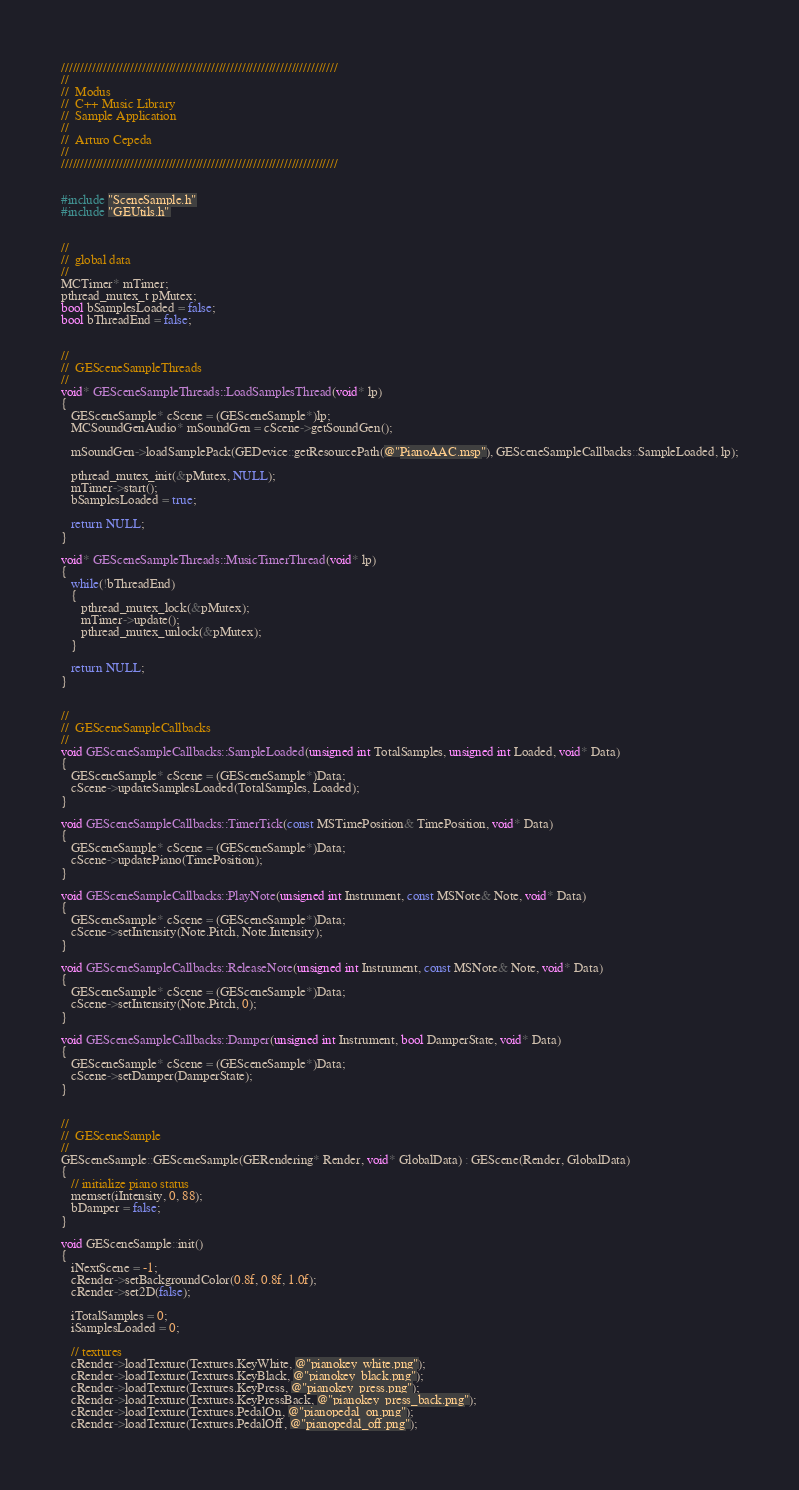<code> <loc_0><loc_0><loc_500><loc_500><_ObjectiveC_>
////////////////////////////////////////////////////////////////////////
//
//  Modus
//  C++ Music Library
//  Sample Application
//
//  Arturo Cepeda
//
////////////////////////////////////////////////////////////////////////


#include "SceneSample.h"
#include "GEUtils.h"


//
//  global data
//
MCTimer* mTimer;
pthread_mutex_t pMutex;
bool bSamplesLoaded = false;
bool bThreadEnd = false;


//
//  GESceneSampleThreads
//
void* GESceneSampleThreads::LoadSamplesThread(void* lp)
{
   GESceneSample* cScene = (GESceneSample*)lp;
   MCSoundGenAudio* mSoundGen = cScene->getSoundGen();
   
   mSoundGen->loadSamplePack(GEDevice::getResourcePath(@"PianoAAC.msp"), GESceneSampleCallbacks::SampleLoaded, lp);
   
   pthread_mutex_init(&pMutex, NULL);
   mTimer->start();
   bSamplesLoaded = true;
   
   return NULL;
}

void* GESceneSampleThreads::MusicTimerThread(void* lp)
{
   while(!bThreadEnd)
   {
      pthread_mutex_lock(&pMutex);
      mTimer->update();
      pthread_mutex_unlock(&pMutex);
   }
   
   return NULL;
}


//
//  GESceneSampleCallbacks
//
void GESceneSampleCallbacks::SampleLoaded(unsigned int TotalSamples, unsigned int Loaded, void* Data)
{
   GESceneSample* cScene = (GESceneSample*)Data;
   cScene->updateSamplesLoaded(TotalSamples, Loaded);
}

void GESceneSampleCallbacks::TimerTick(const MSTimePosition& TimePosition, void* Data)
{
   GESceneSample* cScene = (GESceneSample*)Data;
   cScene->updatePiano(TimePosition);
}

void GESceneSampleCallbacks::PlayNote(unsigned int Instrument, const MSNote& Note, void* Data)
{
   GESceneSample* cScene = (GESceneSample*)Data;   
   cScene->setIntensity(Note.Pitch, Note.Intensity);
}

void GESceneSampleCallbacks::ReleaseNote(unsigned int Instrument, const MSNote& Note, void* Data)
{
   GESceneSample* cScene = (GESceneSample*)Data;
   cScene->setIntensity(Note.Pitch, 0);
}

void GESceneSampleCallbacks::Damper(unsigned int Instrument, bool DamperState, void* Data)
{
   GESceneSample* cScene = (GESceneSample*)Data;
   cScene->setDamper(DamperState);
}


//
//  GESceneSample
//
GESceneSample::GESceneSample(GERendering* Render, void* GlobalData) : GEScene(Render, GlobalData)
{
   // initialize piano status
   memset(iIntensity, 0, 88);
   bDamper = false;
}

void GESceneSample::init()
{   
   iNextScene = -1;
   cRender->setBackgroundColor(0.8f, 0.8f, 1.0f);
   cRender->set2D(false);
   
   iTotalSamples = 0;
   iSamplesLoaded = 0;

   // textures
   cRender->loadTexture(Textures.KeyWhite, @"pianokey_white.png");
   cRender->loadTexture(Textures.KeyBlack, @"pianokey_black.png");
   cRender->loadTexture(Textures.KeyPress, @"pianokey_press.png");
   cRender->loadTexture(Textures.KeyPressBack, @"pianokey_press_back.png");
   cRender->loadTexture(Textures.PedalOn, @"pianopedal_on.png");
   cRender->loadTexture(Textures.PedalOff, @"pianopedal_off.png");</code> 